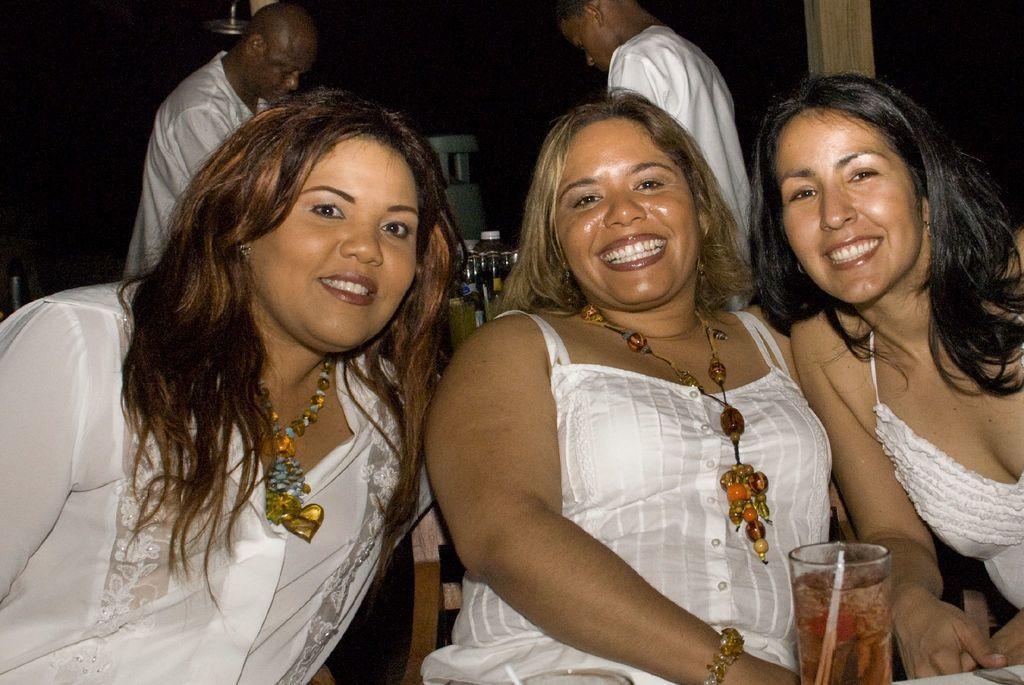Describe this image in one or two sentences. In the image there are three ladies sitting and there is a glass with a straw and liquid in it. Behind the ladies there are two men standing and also there are bottles. There is a wooden pole. And there is a black background. 